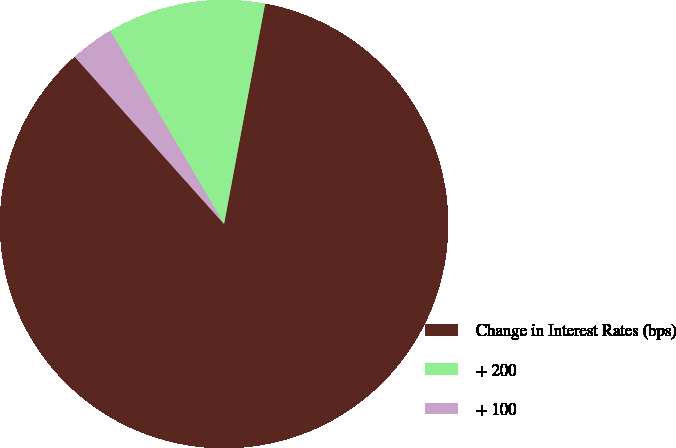Convert chart to OTSL. <chart><loc_0><loc_0><loc_500><loc_500><pie_chart><fcel>Change in Interest Rates (bps)<fcel>+ 200<fcel>+ 100<nl><fcel>85.47%<fcel>11.4%<fcel>3.13%<nl></chart> 